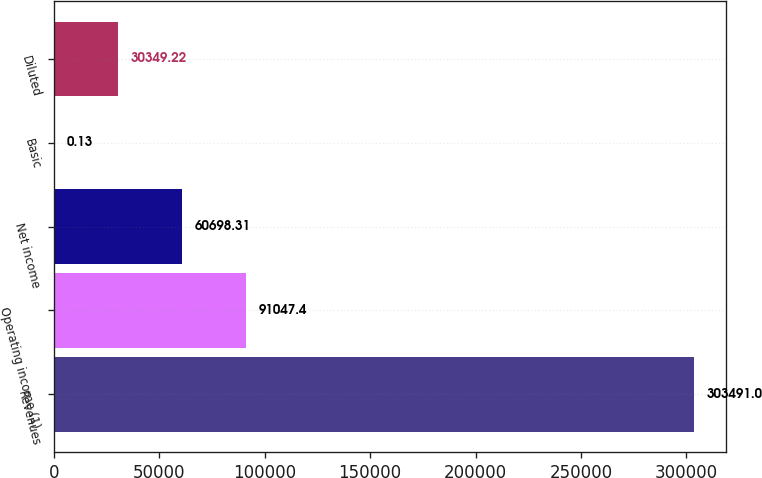Convert chart. <chart><loc_0><loc_0><loc_500><loc_500><bar_chart><fcel>Revenues<fcel>Operating income (1)<fcel>Net income<fcel>Basic<fcel>Diluted<nl><fcel>303491<fcel>91047.4<fcel>60698.3<fcel>0.13<fcel>30349.2<nl></chart> 